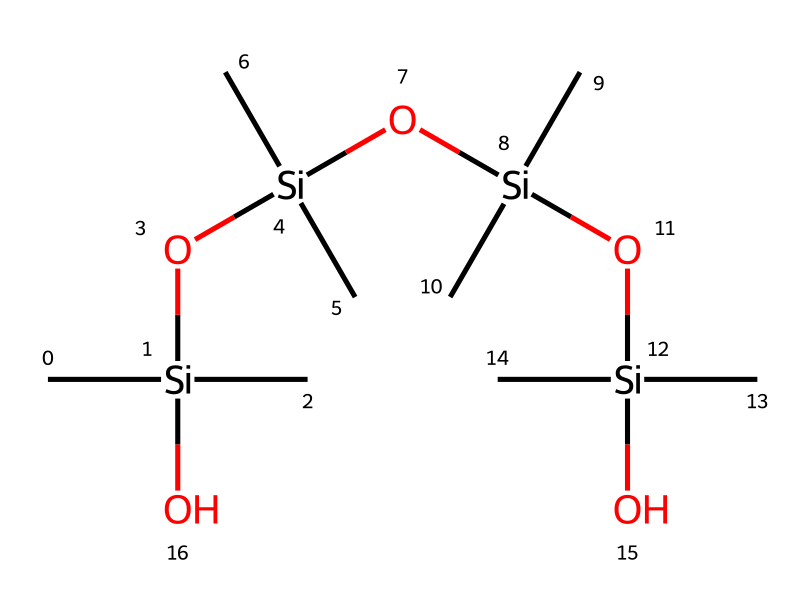What is the primary functional group in polydimethylsiloxane? The chemical structure contains silicon (Si) atoms bonded to oxygen atoms (O), which indicates that the compound has siloxane groups (–Si–O–). Additionally, the presence of carbon (C) suggests that it is organosilicon.
Answer: siloxane How many silicon atoms are present in the structure? By examining the SMILES representation, there are four silicon atoms represented in the sequence found between the oxygen atoms. Each Si is denoted by a “Si” followed by its connections.
Answer: four What type of chemical bond is primarily present in polydimethylsiloxane? The structure showcases a repetitive sequence of siloxane bonds between silicon and oxygen atoms. This indicates a significant amount of Si–O bonds present throughout the chain.
Answer: Si–O How many dimethylsilyl units are present in the structure? Each ‘C’ attached to ‘Si’ represents a methyl group, and since there are three ‘Si’ units in the polymer backbone, we can count each unique ‘Si’ to determine the number of dimethylsilyl units. There are four ‘Si’ leading to a total count of four dimethylsilyl units.
Answer: four What is the ratio of silicon to oxygen in this compound? The SMILES displays four silicon (Si) atoms and one oxygen atom within each siloxane linkage. Hence, the ratio is derived from the total count of Si and O atoms across the whole compound, yielding a ratio of four silicon to three oxygen atoms based on their arrangement.
Answer: four to three What property does the siloxane structure impart to polydimethylsiloxane? The presence of the siloxane structure typically provides unique properties such as flexibility, high thermal stability, and low surface tension, which enhance its use in applications like cushioning materials.
Answer: flexibility 